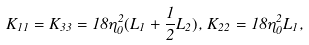Convert formula to latex. <formula><loc_0><loc_0><loc_500><loc_500>K _ { 1 1 } = K _ { 3 3 } = 1 8 \eta _ { 0 } ^ { 2 } ( L _ { 1 } + \frac { 1 } { 2 } L _ { 2 } ) , \, K _ { 2 2 } = 1 8 \eta _ { 0 } ^ { 2 } L _ { 1 } ,</formula> 